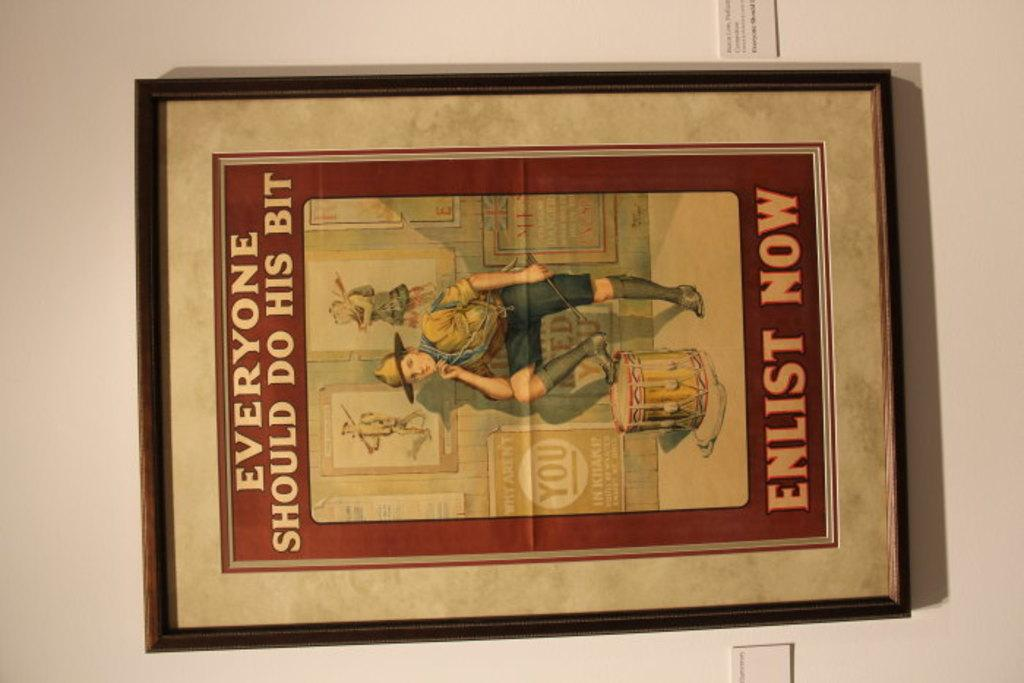<image>
Present a compact description of the photo's key features. A picture to enlist now and everyone should do his bit to help out. 